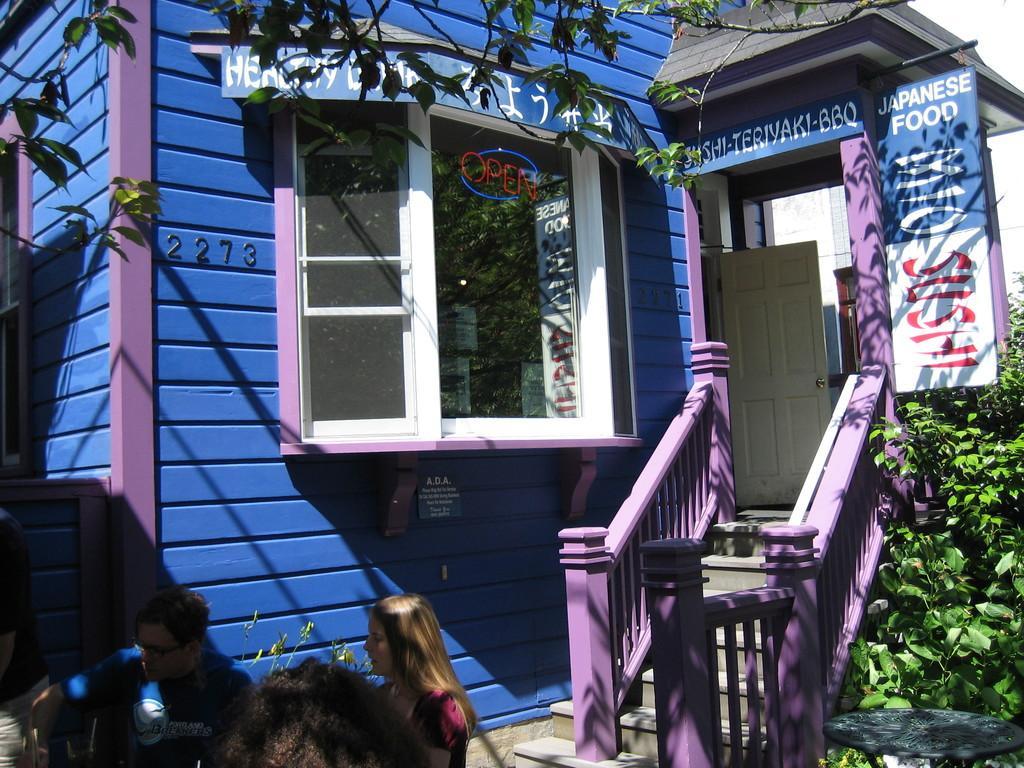Could you give a brief overview of what you see in this image? In this image we can see a store. There are few advertising boards in the image. There is a tree in the image. We can see few plants at the right side of the image. There are few people sitting on the chairs at the bottom of the image. A person is standing at the left side of the image. We can see the reflection of a tree and a board on the glass of the store. 